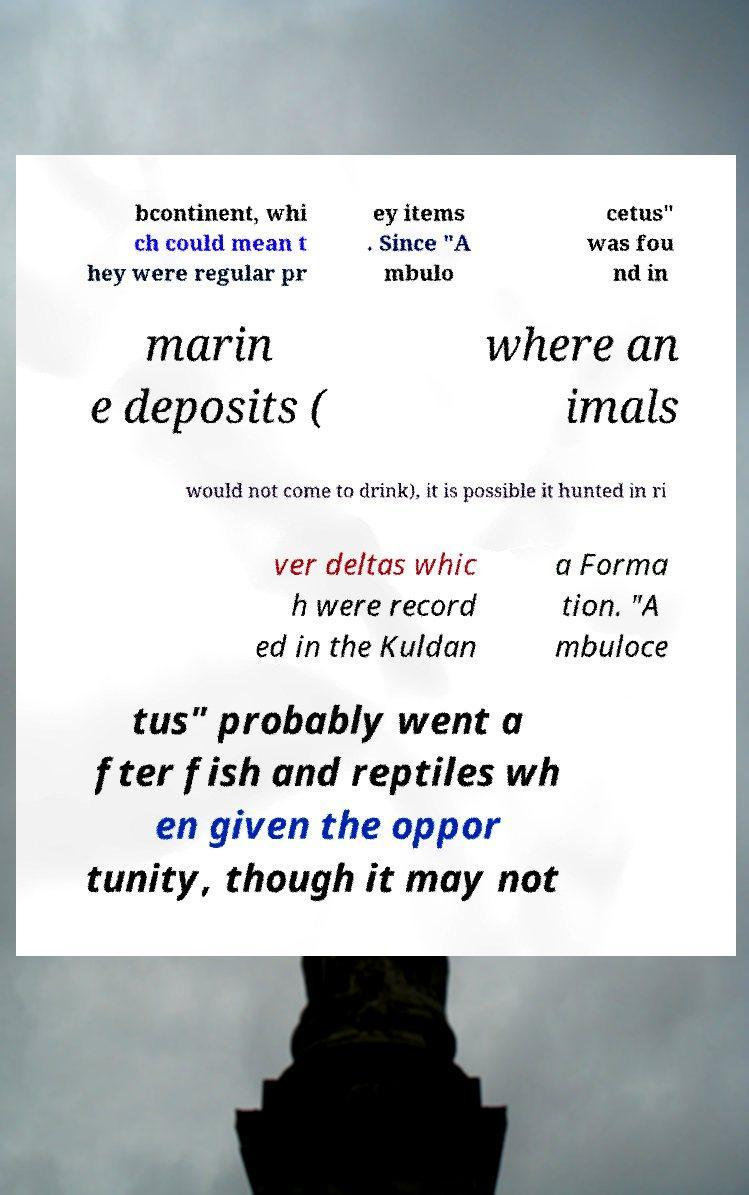Please identify and transcribe the text found in this image. bcontinent, whi ch could mean t hey were regular pr ey items . Since "A mbulo cetus" was fou nd in marin e deposits ( where an imals would not come to drink), it is possible it hunted in ri ver deltas whic h were record ed in the Kuldan a Forma tion. "A mbuloce tus" probably went a fter fish and reptiles wh en given the oppor tunity, though it may not 